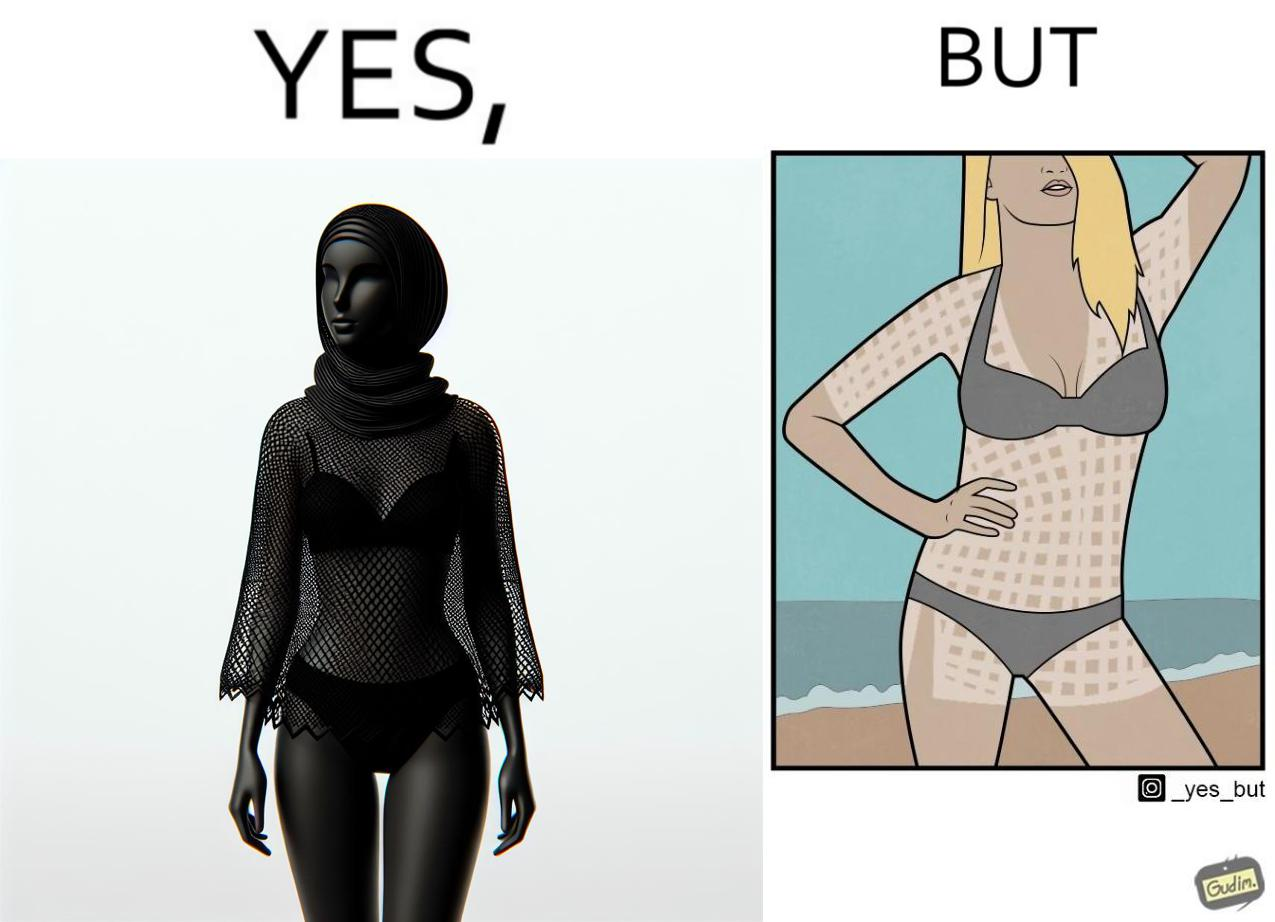What does this image depict? Women wear netted tops while out in the sun on the beach as a beachwear, but when the person removes it, the skin is tanned in the same netted pattern looks weird, and goes against the purpose of using it as beachwear 